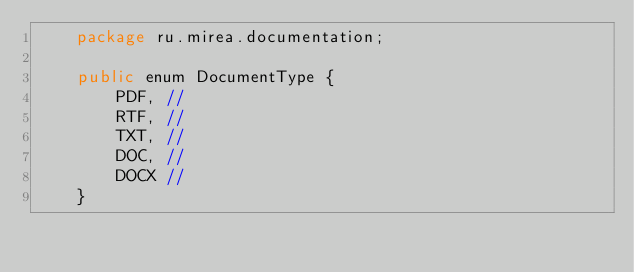Convert code to text. <code><loc_0><loc_0><loc_500><loc_500><_Java_>    package ru.mirea.documentation;

    public enum DocumentType {
        PDF, //
        RTF, //
        TXT, //
        DOC, //
        DOCX //
    }
</code> 